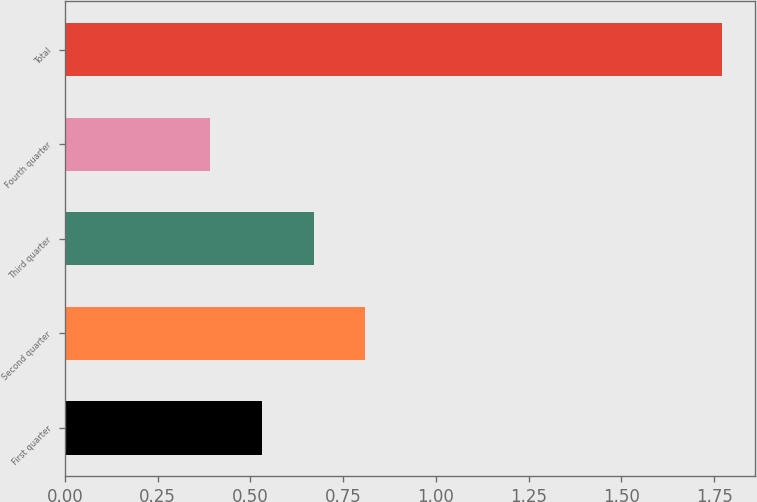Convert chart. <chart><loc_0><loc_0><loc_500><loc_500><bar_chart><fcel>First quarter<fcel>Second quarter<fcel>Third quarter<fcel>Fourth quarter<fcel>Total<nl><fcel>0.53<fcel>0.81<fcel>0.67<fcel>0.39<fcel>1.77<nl></chart> 